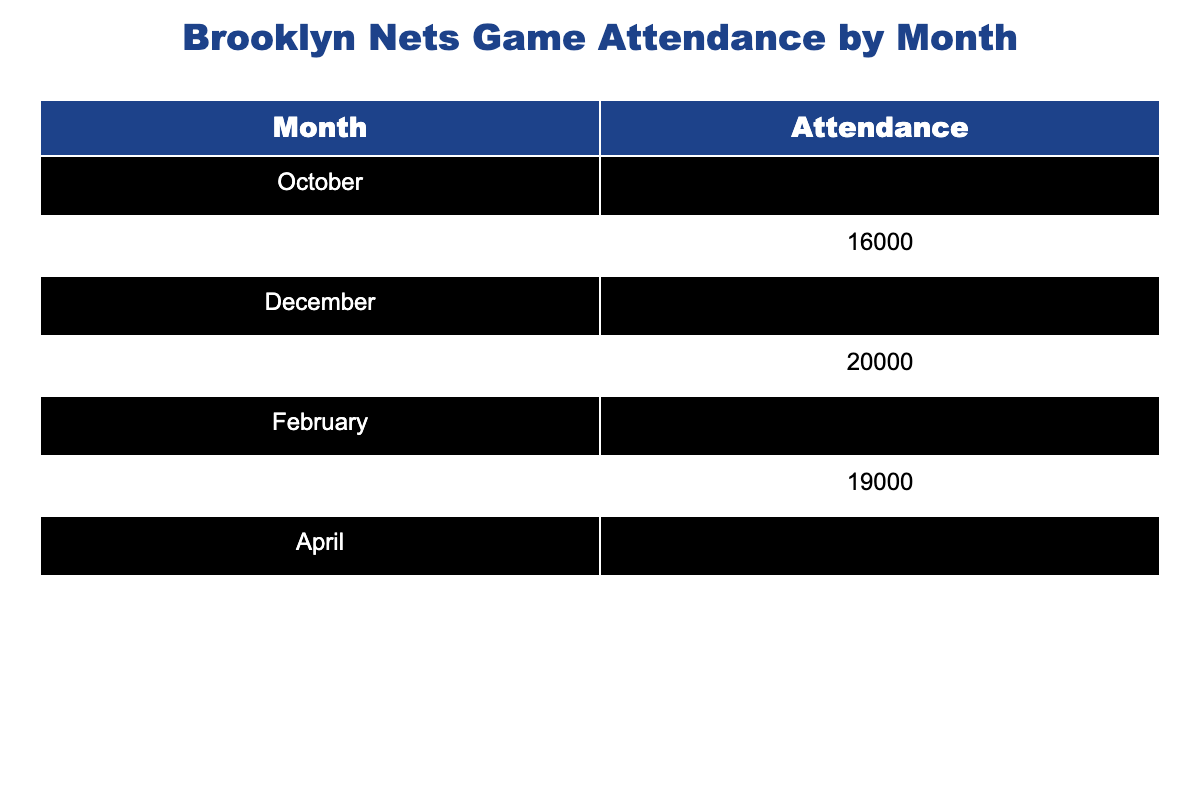What was the highest game attendance for the Brooklyn Nets? The data shows the attendance numbers for each month, with April having the highest attendance at 21,000.
Answer: 21,000 Which month had the lowest game attendance? By looking at the attendance figures, October had the lowest attendance recorded at 15,000.
Answer: 15,000 What is the total attendance from January to March? To find this, we add the attendance for January (20,000), February (17,000), and March (19,000): 20,000 + 17,000 + 19,000 = 56,000.
Answer: 56,000 Did the attendance increase every month? Comparing each month's attendance shows fluctuations, such as a decrease in attendance from February to March, so the statement is false.
Answer: No What is the average game attendance for the months of November and December? The average is calculated by summing November (16,000) and December (18,000) and dividing by 2: (16,000 + 18,000) / 2 = 17,000.
Answer: 17,000 In which month did the attendance exceed 18,000? By reviewing the data, attendance was above 18,000 in December, January, March, and April, confirming multiple months had higher figures.
Answer: Yes What was the difference in attendance between April and October? April's attendance was 21,000 and October's was 15,000. The difference is 21,000 - 15,000 = 6,000.
Answer: 6,000 What percentage of the total attendance does February represent? The total attendance for the season is the sum of all monthly attendances, which equals 117,000. February's attendance is 17,000, so the percentage is (17,000 / 117,000) * 100 ≈ 14.53%.
Answer: Approximately 14.53% Which month had a game attendance lower than 19000? Examining the table reveals that October, November, December, and February had lower attendance figures than 19,000.
Answer: Yes 